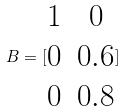Convert formula to latex. <formula><loc_0><loc_0><loc_500><loc_500>B = [ \begin{matrix} 1 & 0 \\ 0 & 0 . 6 \\ 0 & 0 . 8 \end{matrix} ]</formula> 